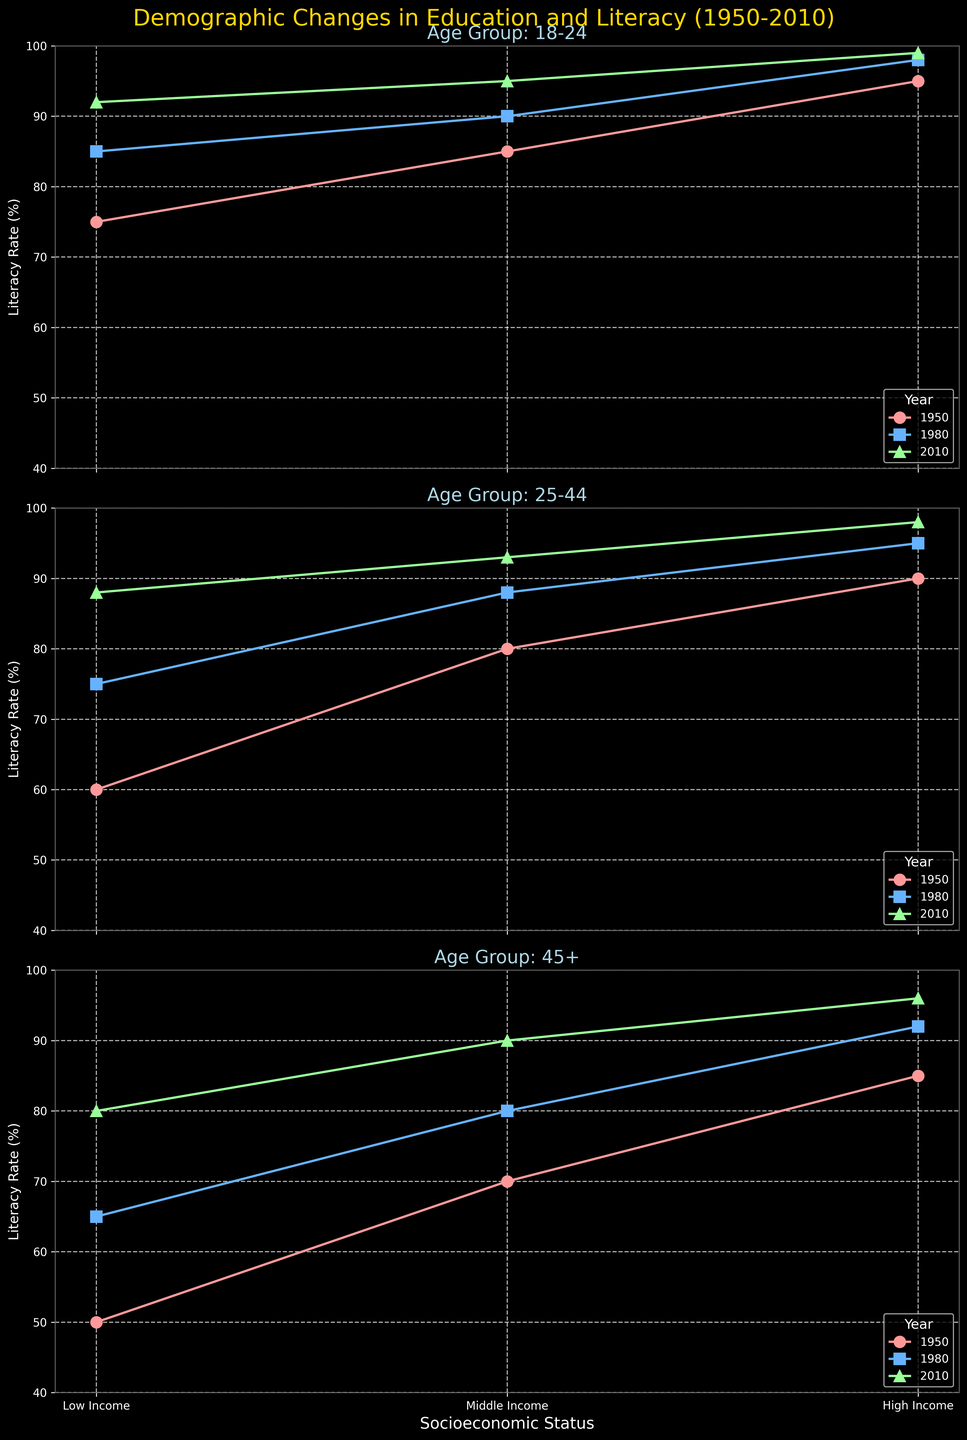What is the overall title of the figure? The title is displayed at the top of the figure and summarizes the content.
Answer: Demographic Changes in Education and Literacy (1950-2010) For the age group 18-24, which socioeconomic status group shows the highest literacy rate in 2010? Locate the subplot for the 18-24 age group and find the line corresponding to 2010. Identify the highest point on this line.
Answer: High Income How does the literacy rate for the low-income group in the 25-44 age group change from 1950 to 2010? Check the literacy rates for the low-income group in the subplot for the 25-44 age group across the three years.
Answer: Increases from 60% to 88% What are the literacy rates for the middle-income group in the 45+ age group over the years? Examine the subplot for the 45+ age group and note the literacy rates for the middle-income group in 1950, 1980, and 2010.
Answer: 70%, 80%, 90% In the 18-24 age group, how much higher is the literacy rate for the middle-income group compared to the low-income group in 1980? From the subplot for the 18-24 age group, find the literacy rates for both income groups in 1980 and calculate the difference.
Answer: 5% higher Which socioeconomic status shows the greatest increase in literacy rate from 1950 to 2010 for the 45+ age group? Identify the difference in literacy rates between 1950 and 2010 for each socioeconomic status in the 45+ subplot.
Answer: Low Income Compare the literacy rate trends for the middle-income group across all age groups from 1950 to 2010. Track the middle-income group's literacy rates across years in each age group's subplot.
Answer: Consistent increase What is the average literacy rate of the high-income group across all age groups in 1950? Calculate the average of the high-income literacy rates across 18-24, 25-44, and 45+ in 1950 from each subplot.
Answer: 90% Which age group experienced the largest absolute increase in literacy rate for the low-income group from 1950 to 2010? Compare the changes in literacy rates for the low-income group across age groups between 1950 and 2010.
Answer: 25-44 (28% increase) What trend can be observed about the education level for the high-income group from 1950 to 2010? Look at the education levels mentioned in the subtitle for high-income groups across the years within each subplot.
Answer: Increasing educational attainment 